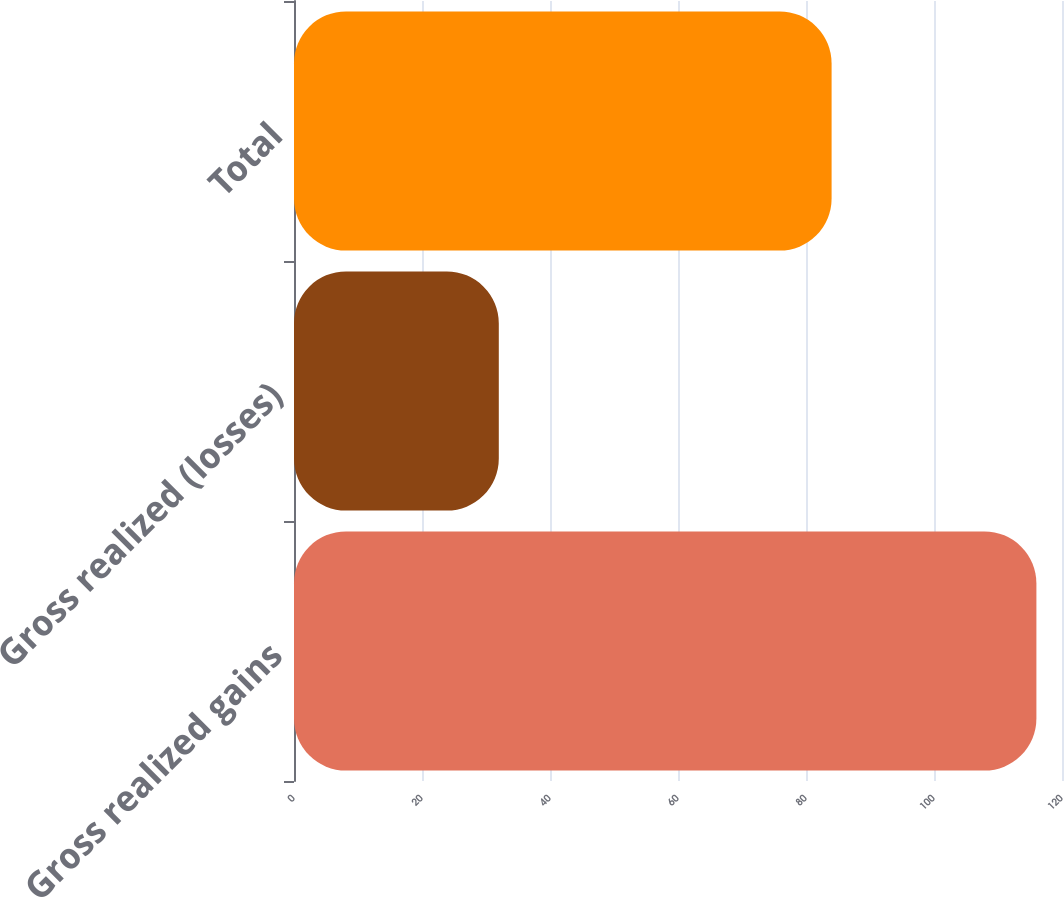Convert chart to OTSL. <chart><loc_0><loc_0><loc_500><loc_500><bar_chart><fcel>Gross realized gains<fcel>Gross realized (losses)<fcel>Total<nl><fcel>116<fcel>32<fcel>84<nl></chart> 